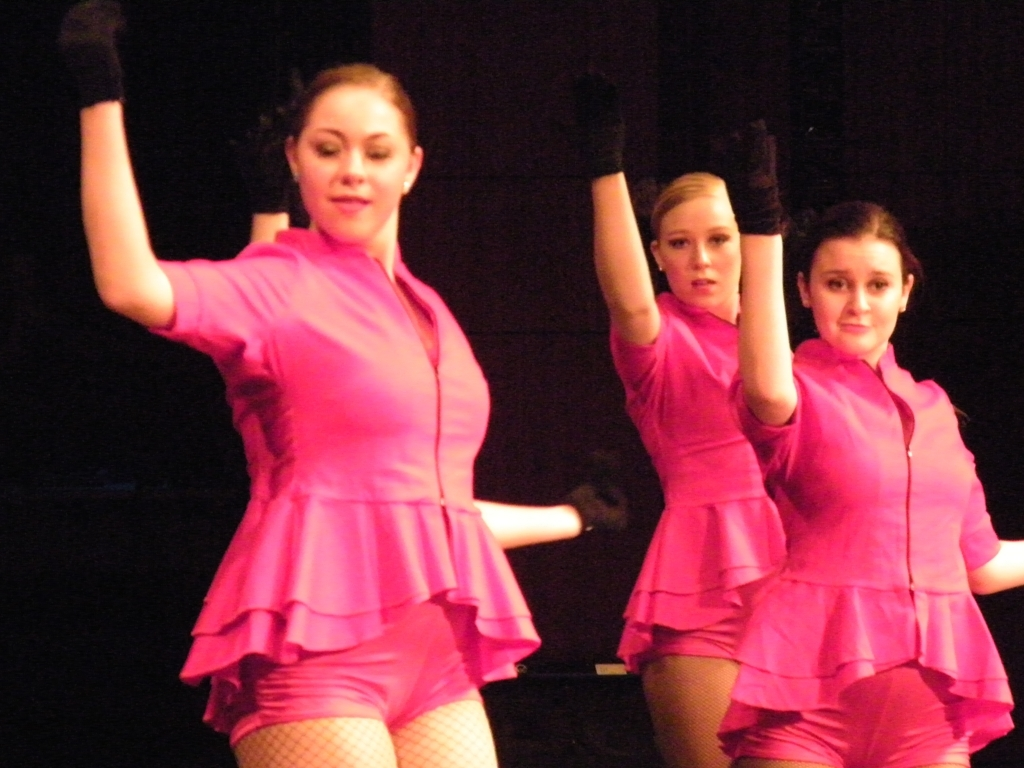What type of dance are the performers doing? The performers appear to be engaged in a contemporary jazz dance, characterized by their dynamic and expressive poses as well as their vibrant costumes. 